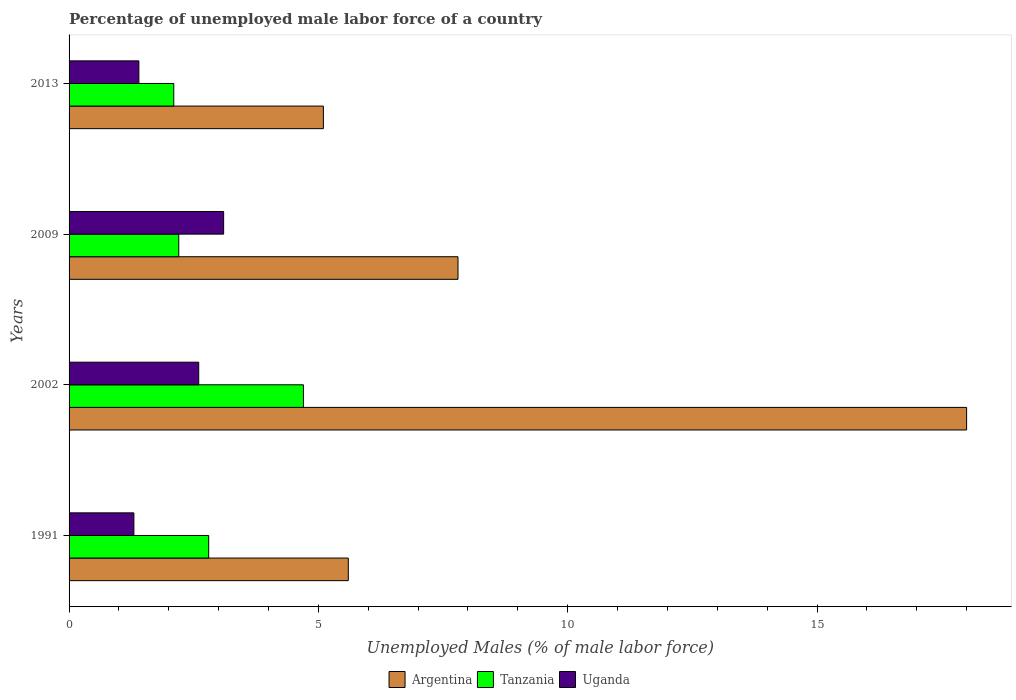How many bars are there on the 2nd tick from the top?
Offer a terse response. 3. In how many cases, is the number of bars for a given year not equal to the number of legend labels?
Provide a succinct answer. 0. What is the percentage of unemployed male labor force in Tanzania in 2002?
Your answer should be very brief. 4.7. Across all years, what is the maximum percentage of unemployed male labor force in Argentina?
Keep it short and to the point. 18. Across all years, what is the minimum percentage of unemployed male labor force in Uganda?
Provide a succinct answer. 1.3. In which year was the percentage of unemployed male labor force in Uganda minimum?
Your answer should be very brief. 1991. What is the total percentage of unemployed male labor force in Uganda in the graph?
Ensure brevity in your answer.  8.4. What is the difference between the percentage of unemployed male labor force in Uganda in 1991 and that in 2009?
Your answer should be compact. -1.8. What is the difference between the percentage of unemployed male labor force in Uganda in 1991 and the percentage of unemployed male labor force in Tanzania in 2002?
Offer a terse response. -3.4. What is the average percentage of unemployed male labor force in Uganda per year?
Offer a terse response. 2.1. In the year 2009, what is the difference between the percentage of unemployed male labor force in Argentina and percentage of unemployed male labor force in Tanzania?
Your answer should be very brief. 5.6. What is the ratio of the percentage of unemployed male labor force in Uganda in 2009 to that in 2013?
Provide a short and direct response. 2.21. Is the percentage of unemployed male labor force in Argentina in 1991 less than that in 2002?
Keep it short and to the point. Yes. Is the difference between the percentage of unemployed male labor force in Argentina in 2002 and 2009 greater than the difference between the percentage of unemployed male labor force in Tanzania in 2002 and 2009?
Keep it short and to the point. Yes. What is the difference between the highest and the second highest percentage of unemployed male labor force in Tanzania?
Your response must be concise. 1.9. What is the difference between the highest and the lowest percentage of unemployed male labor force in Uganda?
Offer a very short reply. 1.8. Is the sum of the percentage of unemployed male labor force in Argentina in 2002 and 2009 greater than the maximum percentage of unemployed male labor force in Tanzania across all years?
Ensure brevity in your answer.  Yes. What does the 1st bar from the top in 2013 represents?
Give a very brief answer. Uganda. What does the 3rd bar from the bottom in 2002 represents?
Provide a short and direct response. Uganda. Is it the case that in every year, the sum of the percentage of unemployed male labor force in Tanzania and percentage of unemployed male labor force in Argentina is greater than the percentage of unemployed male labor force in Uganda?
Offer a terse response. Yes. How many bars are there?
Provide a short and direct response. 12. How many years are there in the graph?
Keep it short and to the point. 4. What is the difference between two consecutive major ticks on the X-axis?
Provide a succinct answer. 5. Are the values on the major ticks of X-axis written in scientific E-notation?
Provide a short and direct response. No. Where does the legend appear in the graph?
Your answer should be very brief. Bottom center. How many legend labels are there?
Your response must be concise. 3. How are the legend labels stacked?
Give a very brief answer. Horizontal. What is the title of the graph?
Provide a succinct answer. Percentage of unemployed male labor force of a country. Does "Qatar" appear as one of the legend labels in the graph?
Provide a succinct answer. No. What is the label or title of the X-axis?
Provide a succinct answer. Unemployed Males (% of male labor force). What is the label or title of the Y-axis?
Provide a short and direct response. Years. What is the Unemployed Males (% of male labor force) in Argentina in 1991?
Keep it short and to the point. 5.6. What is the Unemployed Males (% of male labor force) in Tanzania in 1991?
Provide a short and direct response. 2.8. What is the Unemployed Males (% of male labor force) of Uganda in 1991?
Provide a short and direct response. 1.3. What is the Unemployed Males (% of male labor force) in Tanzania in 2002?
Provide a short and direct response. 4.7. What is the Unemployed Males (% of male labor force) of Uganda in 2002?
Offer a very short reply. 2.6. What is the Unemployed Males (% of male labor force) in Argentina in 2009?
Provide a short and direct response. 7.8. What is the Unemployed Males (% of male labor force) of Tanzania in 2009?
Ensure brevity in your answer.  2.2. What is the Unemployed Males (% of male labor force) in Uganda in 2009?
Offer a terse response. 3.1. What is the Unemployed Males (% of male labor force) in Argentina in 2013?
Give a very brief answer. 5.1. What is the Unemployed Males (% of male labor force) of Tanzania in 2013?
Ensure brevity in your answer.  2.1. What is the Unemployed Males (% of male labor force) of Uganda in 2013?
Provide a short and direct response. 1.4. Across all years, what is the maximum Unemployed Males (% of male labor force) in Argentina?
Your response must be concise. 18. Across all years, what is the maximum Unemployed Males (% of male labor force) in Tanzania?
Offer a very short reply. 4.7. Across all years, what is the maximum Unemployed Males (% of male labor force) in Uganda?
Offer a very short reply. 3.1. Across all years, what is the minimum Unemployed Males (% of male labor force) in Argentina?
Provide a short and direct response. 5.1. Across all years, what is the minimum Unemployed Males (% of male labor force) in Tanzania?
Ensure brevity in your answer.  2.1. Across all years, what is the minimum Unemployed Males (% of male labor force) in Uganda?
Your answer should be very brief. 1.3. What is the total Unemployed Males (% of male labor force) of Argentina in the graph?
Offer a very short reply. 36.5. What is the total Unemployed Males (% of male labor force) in Tanzania in the graph?
Provide a short and direct response. 11.8. What is the difference between the Unemployed Males (% of male labor force) of Argentina in 1991 and that in 2002?
Offer a terse response. -12.4. What is the difference between the Unemployed Males (% of male labor force) of Uganda in 1991 and that in 2002?
Offer a very short reply. -1.3. What is the difference between the Unemployed Males (% of male labor force) of Tanzania in 1991 and that in 2013?
Keep it short and to the point. 0.7. What is the difference between the Unemployed Males (% of male labor force) of Argentina in 2002 and that in 2009?
Keep it short and to the point. 10.2. What is the difference between the Unemployed Males (% of male labor force) in Tanzania in 2002 and that in 2009?
Your answer should be compact. 2.5. What is the difference between the Unemployed Males (% of male labor force) in Uganda in 2002 and that in 2009?
Give a very brief answer. -0.5. What is the difference between the Unemployed Males (% of male labor force) of Tanzania in 2002 and that in 2013?
Your answer should be very brief. 2.6. What is the difference between the Unemployed Males (% of male labor force) in Argentina in 2009 and that in 2013?
Make the answer very short. 2.7. What is the difference between the Unemployed Males (% of male labor force) of Tanzania in 1991 and the Unemployed Males (% of male labor force) of Uganda in 2009?
Your answer should be very brief. -0.3. What is the difference between the Unemployed Males (% of male labor force) in Argentina in 1991 and the Unemployed Males (% of male labor force) in Uganda in 2013?
Your answer should be compact. 4.2. What is the difference between the Unemployed Males (% of male labor force) in Tanzania in 1991 and the Unemployed Males (% of male labor force) in Uganda in 2013?
Your answer should be compact. 1.4. What is the difference between the Unemployed Males (% of male labor force) in Argentina in 2002 and the Unemployed Males (% of male labor force) in Tanzania in 2009?
Offer a terse response. 15.8. What is the difference between the Unemployed Males (% of male labor force) of Argentina in 2002 and the Unemployed Males (% of male labor force) of Uganda in 2009?
Your answer should be very brief. 14.9. What is the difference between the Unemployed Males (% of male labor force) in Argentina in 2002 and the Unemployed Males (% of male labor force) in Uganda in 2013?
Your answer should be compact. 16.6. What is the difference between the Unemployed Males (% of male labor force) of Argentina in 2009 and the Unemployed Males (% of male labor force) of Tanzania in 2013?
Make the answer very short. 5.7. What is the difference between the Unemployed Males (% of male labor force) of Argentina in 2009 and the Unemployed Males (% of male labor force) of Uganda in 2013?
Your answer should be compact. 6.4. What is the average Unemployed Males (% of male labor force) in Argentina per year?
Offer a terse response. 9.12. What is the average Unemployed Males (% of male labor force) in Tanzania per year?
Offer a very short reply. 2.95. In the year 1991, what is the difference between the Unemployed Males (% of male labor force) of Argentina and Unemployed Males (% of male labor force) of Tanzania?
Your response must be concise. 2.8. In the year 1991, what is the difference between the Unemployed Males (% of male labor force) in Argentina and Unemployed Males (% of male labor force) in Uganda?
Offer a terse response. 4.3. In the year 1991, what is the difference between the Unemployed Males (% of male labor force) of Tanzania and Unemployed Males (% of male labor force) of Uganda?
Provide a succinct answer. 1.5. In the year 2002, what is the difference between the Unemployed Males (% of male labor force) in Argentina and Unemployed Males (% of male labor force) in Tanzania?
Your answer should be compact. 13.3. In the year 2002, what is the difference between the Unemployed Males (% of male labor force) in Tanzania and Unemployed Males (% of male labor force) in Uganda?
Your answer should be compact. 2.1. In the year 2009, what is the difference between the Unemployed Males (% of male labor force) of Argentina and Unemployed Males (% of male labor force) of Uganda?
Your response must be concise. 4.7. In the year 2013, what is the difference between the Unemployed Males (% of male labor force) in Argentina and Unemployed Males (% of male labor force) in Tanzania?
Provide a short and direct response. 3. In the year 2013, what is the difference between the Unemployed Males (% of male labor force) of Argentina and Unemployed Males (% of male labor force) of Uganda?
Your answer should be compact. 3.7. What is the ratio of the Unemployed Males (% of male labor force) in Argentina in 1991 to that in 2002?
Offer a terse response. 0.31. What is the ratio of the Unemployed Males (% of male labor force) in Tanzania in 1991 to that in 2002?
Make the answer very short. 0.6. What is the ratio of the Unemployed Males (% of male labor force) of Uganda in 1991 to that in 2002?
Your answer should be compact. 0.5. What is the ratio of the Unemployed Males (% of male labor force) in Argentina in 1991 to that in 2009?
Provide a short and direct response. 0.72. What is the ratio of the Unemployed Males (% of male labor force) in Tanzania in 1991 to that in 2009?
Offer a terse response. 1.27. What is the ratio of the Unemployed Males (% of male labor force) in Uganda in 1991 to that in 2009?
Keep it short and to the point. 0.42. What is the ratio of the Unemployed Males (% of male labor force) of Argentina in 1991 to that in 2013?
Offer a very short reply. 1.1. What is the ratio of the Unemployed Males (% of male labor force) in Argentina in 2002 to that in 2009?
Your answer should be compact. 2.31. What is the ratio of the Unemployed Males (% of male labor force) of Tanzania in 2002 to that in 2009?
Provide a short and direct response. 2.14. What is the ratio of the Unemployed Males (% of male labor force) of Uganda in 2002 to that in 2009?
Keep it short and to the point. 0.84. What is the ratio of the Unemployed Males (% of male labor force) in Argentina in 2002 to that in 2013?
Offer a terse response. 3.53. What is the ratio of the Unemployed Males (% of male labor force) of Tanzania in 2002 to that in 2013?
Give a very brief answer. 2.24. What is the ratio of the Unemployed Males (% of male labor force) of Uganda in 2002 to that in 2013?
Give a very brief answer. 1.86. What is the ratio of the Unemployed Males (% of male labor force) of Argentina in 2009 to that in 2013?
Ensure brevity in your answer.  1.53. What is the ratio of the Unemployed Males (% of male labor force) of Tanzania in 2009 to that in 2013?
Your response must be concise. 1.05. What is the ratio of the Unemployed Males (% of male labor force) in Uganda in 2009 to that in 2013?
Give a very brief answer. 2.21. What is the difference between the highest and the second highest Unemployed Males (% of male labor force) of Tanzania?
Your answer should be very brief. 1.9. What is the difference between the highest and the second highest Unemployed Males (% of male labor force) in Uganda?
Make the answer very short. 0.5. What is the difference between the highest and the lowest Unemployed Males (% of male labor force) of Argentina?
Give a very brief answer. 12.9. What is the difference between the highest and the lowest Unemployed Males (% of male labor force) of Tanzania?
Give a very brief answer. 2.6. 